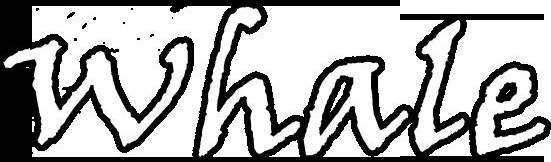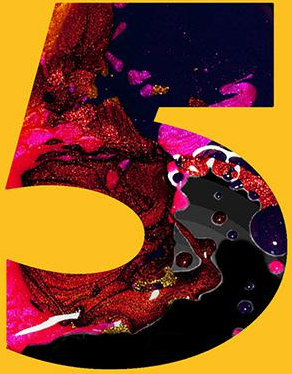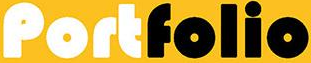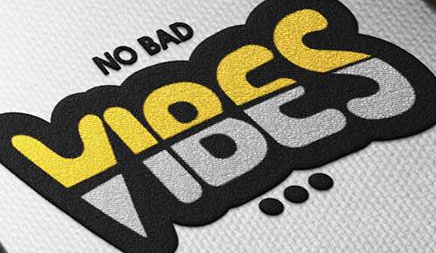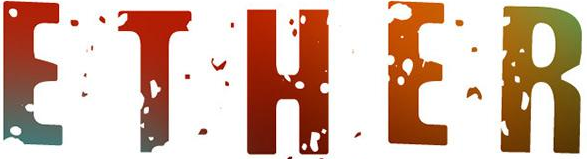Identify the words shown in these images in order, separated by a semicolon. whale; 5; Portfolio; VIBES; ETHER 